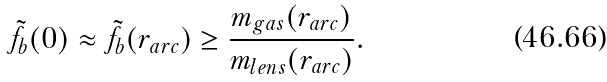<formula> <loc_0><loc_0><loc_500><loc_500>\tilde { f } _ { b } ( 0 ) \approx \tilde { f } _ { b } ( r _ { a r c } ) \geq \frac { m _ { g a s } ( r _ { a r c } ) } { m _ { l e n s } ( r _ { a r c } ) } .</formula> 